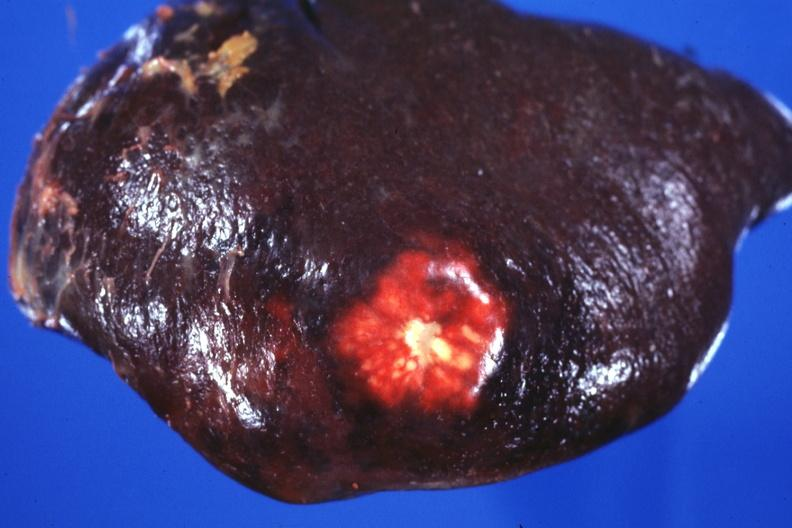does this image show external view of spleen with obvious metastatic nodule beneath capsule?
Answer the question using a single word or phrase. Yes 